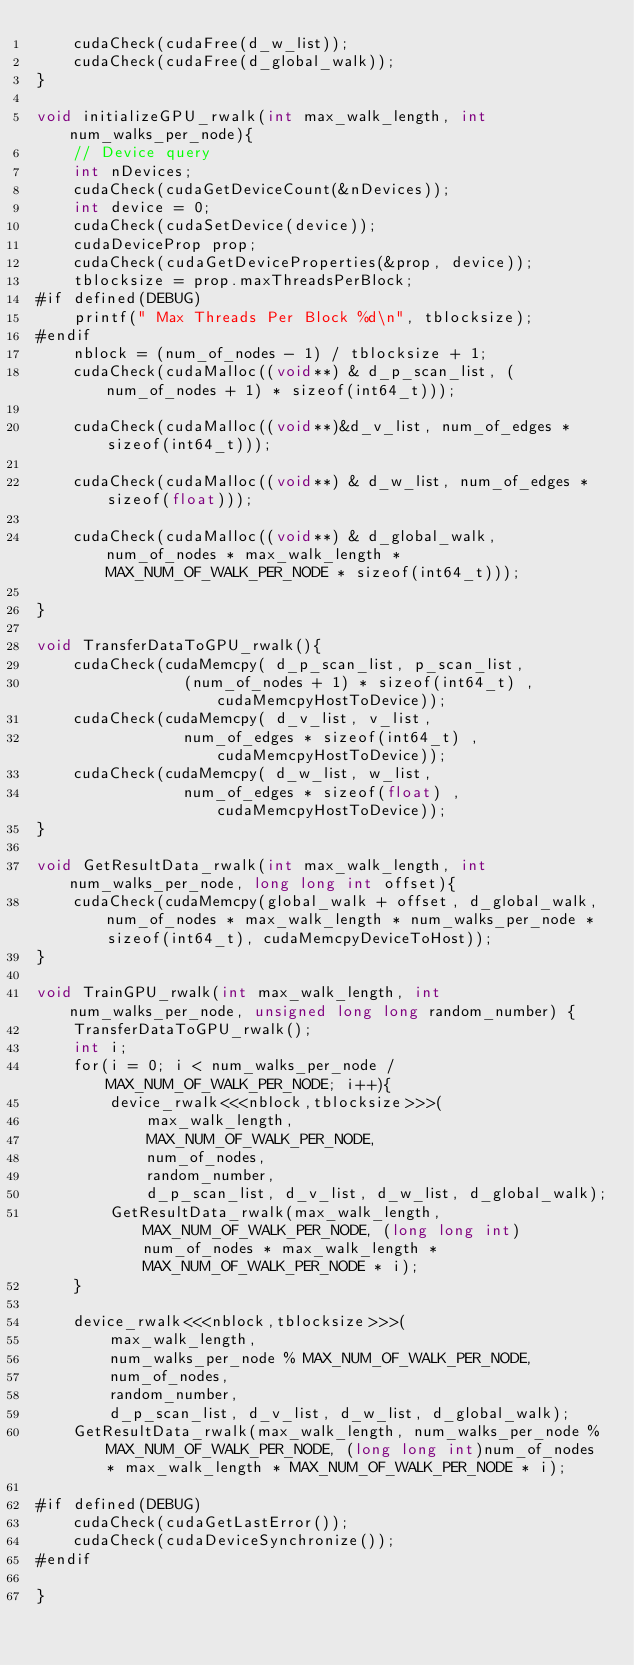Convert code to text. <code><loc_0><loc_0><loc_500><loc_500><_Cuda_>	cudaCheck(cudaFree(d_w_list));
	cudaCheck(cudaFree(d_global_walk));
}

void initializeGPU_rwalk(int max_walk_length, int num_walks_per_node){
	// Device query
	int nDevices;
	cudaCheck(cudaGetDeviceCount(&nDevices));
	int device = 0;
	cudaCheck(cudaSetDevice(device));
	cudaDeviceProp prop;
	cudaCheck(cudaGetDeviceProperties(&prop, device));
	tblocksize = prop.maxThreadsPerBlock;
#if defined(DEBUG)
	printf(" Max Threads Per Block %d\n", tblocksize);
#endif
	nblock = (num_of_nodes - 1) / tblocksize + 1;	
	cudaCheck(cudaMalloc((void**) & d_p_scan_list, (num_of_nodes + 1) * sizeof(int64_t)));

	cudaCheck(cudaMalloc((void**)&d_v_list, num_of_edges * sizeof(int64_t)));

	cudaCheck(cudaMalloc((void**) & d_w_list, num_of_edges * sizeof(float)));

	cudaCheck(cudaMalloc((void**) & d_global_walk, num_of_nodes * max_walk_length * MAX_NUM_OF_WALK_PER_NODE * sizeof(int64_t)));

}

void TransferDataToGPU_rwalk(){
	cudaCheck(cudaMemcpy( d_p_scan_list, p_scan_list,
				(num_of_nodes + 1) * sizeof(int64_t) , cudaMemcpyHostToDevice));
	cudaCheck(cudaMemcpy( d_v_list, v_list,
				num_of_edges * sizeof(int64_t) , cudaMemcpyHostToDevice));
	cudaCheck(cudaMemcpy( d_w_list, w_list,
				num_of_edges * sizeof(float) , cudaMemcpyHostToDevice));
}

void GetResultData_rwalk(int max_walk_length, int num_walks_per_node, long long int offset){
	cudaCheck(cudaMemcpy(global_walk + offset, d_global_walk, num_of_nodes * max_walk_length * num_walks_per_node * sizeof(int64_t), cudaMemcpyDeviceToHost));
}

void TrainGPU_rwalk(int max_walk_length, int num_walks_per_node, unsigned long long random_number) {
	TransferDataToGPU_rwalk();
	int i;	
	for(i = 0; i < num_walks_per_node / MAX_NUM_OF_WALK_PER_NODE; i++){
		device_rwalk<<<nblock,tblocksize>>>(
			max_walk_length,
			MAX_NUM_OF_WALK_PER_NODE,
			num_of_nodes,
			random_number, 
			d_p_scan_list, d_v_list, d_w_list, d_global_walk);
		GetResultData_rwalk(max_walk_length, MAX_NUM_OF_WALK_PER_NODE, (long long int)num_of_nodes * max_walk_length * MAX_NUM_OF_WALK_PER_NODE * i);
	}

	device_rwalk<<<nblock,tblocksize>>>(
		max_walk_length,
		num_walks_per_node % MAX_NUM_OF_WALK_PER_NODE,
		num_of_nodes,
		random_number, 
		d_p_scan_list, d_v_list, d_w_list, d_global_walk);
	GetResultData_rwalk(max_walk_length, num_walks_per_node % MAX_NUM_OF_WALK_PER_NODE, (long long int)num_of_nodes * max_walk_length * MAX_NUM_OF_WALK_PER_NODE * i);
	
#if defined(DEBUG)
	cudaCheck(cudaGetLastError());
	cudaCheck(cudaDeviceSynchronize());
#endif

}

</code> 